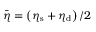<formula> <loc_0><loc_0><loc_500><loc_500>\bar { \eta } = \left ( \eta _ { s } + \eta _ { d } \right ) / 2</formula> 